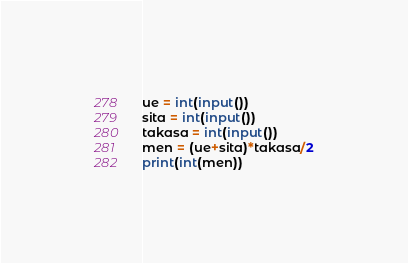<code> <loc_0><loc_0><loc_500><loc_500><_Python_>ue = int(input())
sita = int(input())
takasa = int(input())
men = (ue+sita)*takasa/2
print(int(men))
</code> 